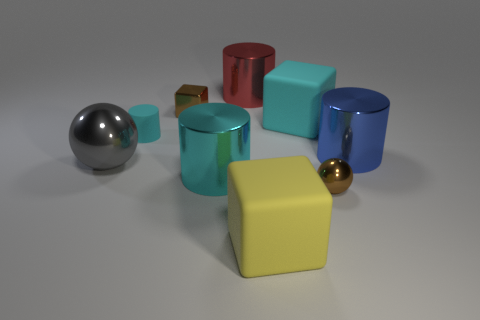There is a object that is both in front of the cyan shiny cylinder and to the right of the yellow thing; what material is it made of?
Offer a very short reply. Metal. Are there fewer red things that are in front of the tiny metallic block than big gray metal things that are in front of the brown ball?
Your response must be concise. No. How many other objects are there of the same size as the red shiny thing?
Your answer should be compact. 5. What is the shape of the brown thing that is in front of the small brown thing on the left side of the metal cylinder behind the brown metal cube?
Make the answer very short. Sphere. How many brown objects are tiny metallic balls or blocks?
Offer a very short reply. 2. There is a ball on the left side of the tiny cylinder; how many blue cylinders are behind it?
Your answer should be very brief. 1. Is there any other thing that is the same color as the large metallic sphere?
Provide a short and direct response. No. There is a gray object that is made of the same material as the large blue cylinder; what shape is it?
Give a very brief answer. Sphere. Is the large ball the same color as the small ball?
Provide a short and direct response. No. Is the material of the brown thing on the right side of the big red cylinder the same as the brown object behind the tiny rubber cylinder?
Ensure brevity in your answer.  Yes. 